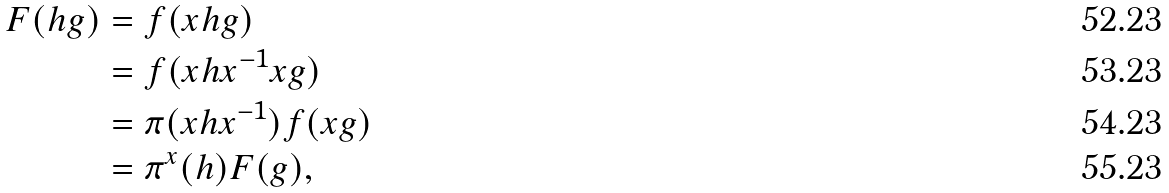Convert formula to latex. <formula><loc_0><loc_0><loc_500><loc_500>F ( h g ) & = f ( x h g ) \\ & = f ( x h x ^ { - 1 } x g ) \\ & = \pi ( x h x ^ { - 1 } ) f ( x g ) \\ & = \pi ^ { x } ( h ) F ( g ) ,</formula> 